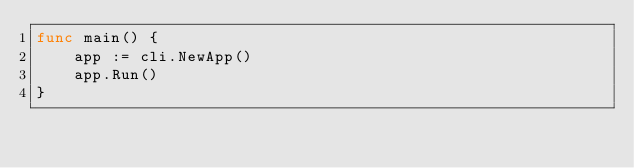Convert code to text. <code><loc_0><loc_0><loc_500><loc_500><_Go_>func main() {
	app := cli.NewApp()
	app.Run()
}
</code> 